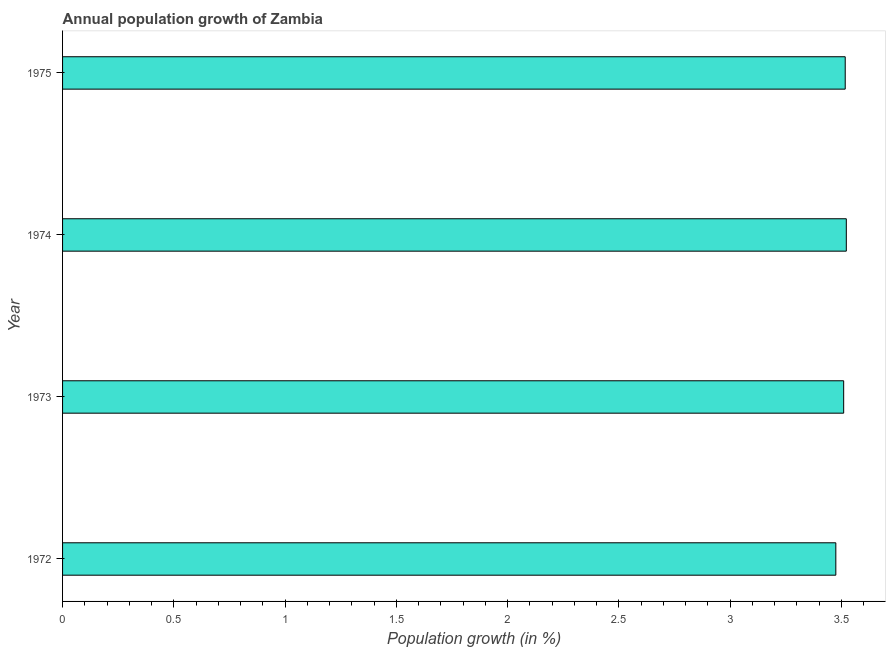Does the graph contain grids?
Your answer should be very brief. No. What is the title of the graph?
Provide a short and direct response. Annual population growth of Zambia. What is the label or title of the X-axis?
Ensure brevity in your answer.  Population growth (in %). What is the label or title of the Y-axis?
Provide a short and direct response. Year. What is the population growth in 1972?
Offer a terse response. 3.47. Across all years, what is the maximum population growth?
Ensure brevity in your answer.  3.52. Across all years, what is the minimum population growth?
Ensure brevity in your answer.  3.47. In which year was the population growth maximum?
Offer a terse response. 1974. What is the sum of the population growth?
Offer a very short reply. 14.02. What is the difference between the population growth in 1972 and 1974?
Your answer should be very brief. -0.05. What is the average population growth per year?
Your answer should be compact. 3.51. What is the median population growth?
Provide a short and direct response. 3.51. Do a majority of the years between 1974 and 1973 (inclusive) have population growth greater than 1.6 %?
Keep it short and to the point. No. Is the difference between the population growth in 1973 and 1974 greater than the difference between any two years?
Give a very brief answer. No. What is the difference between the highest and the second highest population growth?
Ensure brevity in your answer.  0.01. What is the difference between the highest and the lowest population growth?
Offer a terse response. 0.05. In how many years, is the population growth greater than the average population growth taken over all years?
Give a very brief answer. 3. How many years are there in the graph?
Your answer should be very brief. 4. What is the difference between two consecutive major ticks on the X-axis?
Provide a succinct answer. 0.5. What is the Population growth (in %) of 1972?
Offer a very short reply. 3.47. What is the Population growth (in %) in 1973?
Your response must be concise. 3.51. What is the Population growth (in %) in 1974?
Offer a terse response. 3.52. What is the Population growth (in %) of 1975?
Your answer should be very brief. 3.52. What is the difference between the Population growth (in %) in 1972 and 1973?
Ensure brevity in your answer.  -0.04. What is the difference between the Population growth (in %) in 1972 and 1974?
Give a very brief answer. -0.05. What is the difference between the Population growth (in %) in 1972 and 1975?
Your response must be concise. -0.04. What is the difference between the Population growth (in %) in 1973 and 1974?
Provide a succinct answer. -0.01. What is the difference between the Population growth (in %) in 1973 and 1975?
Make the answer very short. -0.01. What is the difference between the Population growth (in %) in 1974 and 1975?
Make the answer very short. 0. What is the ratio of the Population growth (in %) in 1972 to that in 1974?
Keep it short and to the point. 0.99. What is the ratio of the Population growth (in %) in 1972 to that in 1975?
Your answer should be very brief. 0.99. What is the ratio of the Population growth (in %) in 1973 to that in 1975?
Ensure brevity in your answer.  1. What is the ratio of the Population growth (in %) in 1974 to that in 1975?
Give a very brief answer. 1. 